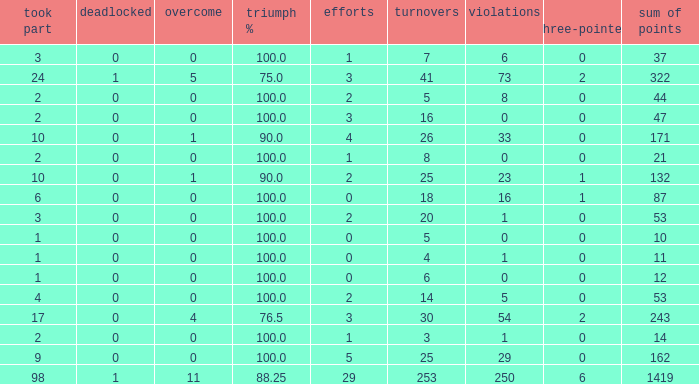What is the least number of penalties he got when his point total was over 1419 in more than 98 games? None. 